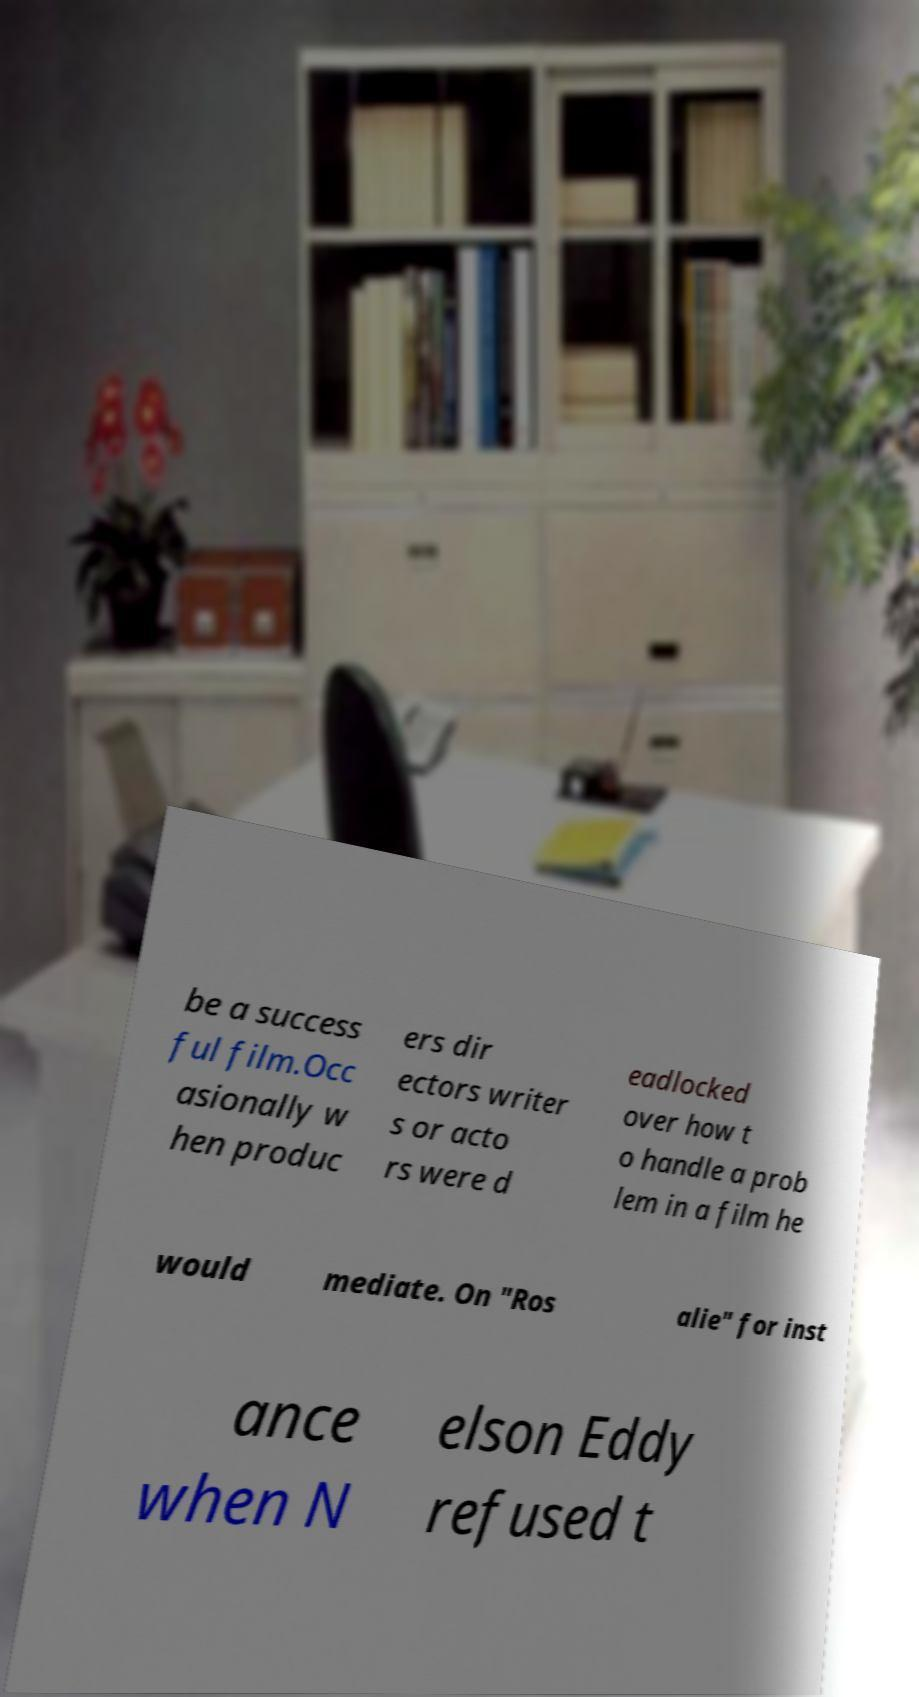For documentation purposes, I need the text within this image transcribed. Could you provide that? be a success ful film.Occ asionally w hen produc ers dir ectors writer s or acto rs were d eadlocked over how t o handle a prob lem in a film he would mediate. On "Ros alie" for inst ance when N elson Eddy refused t 